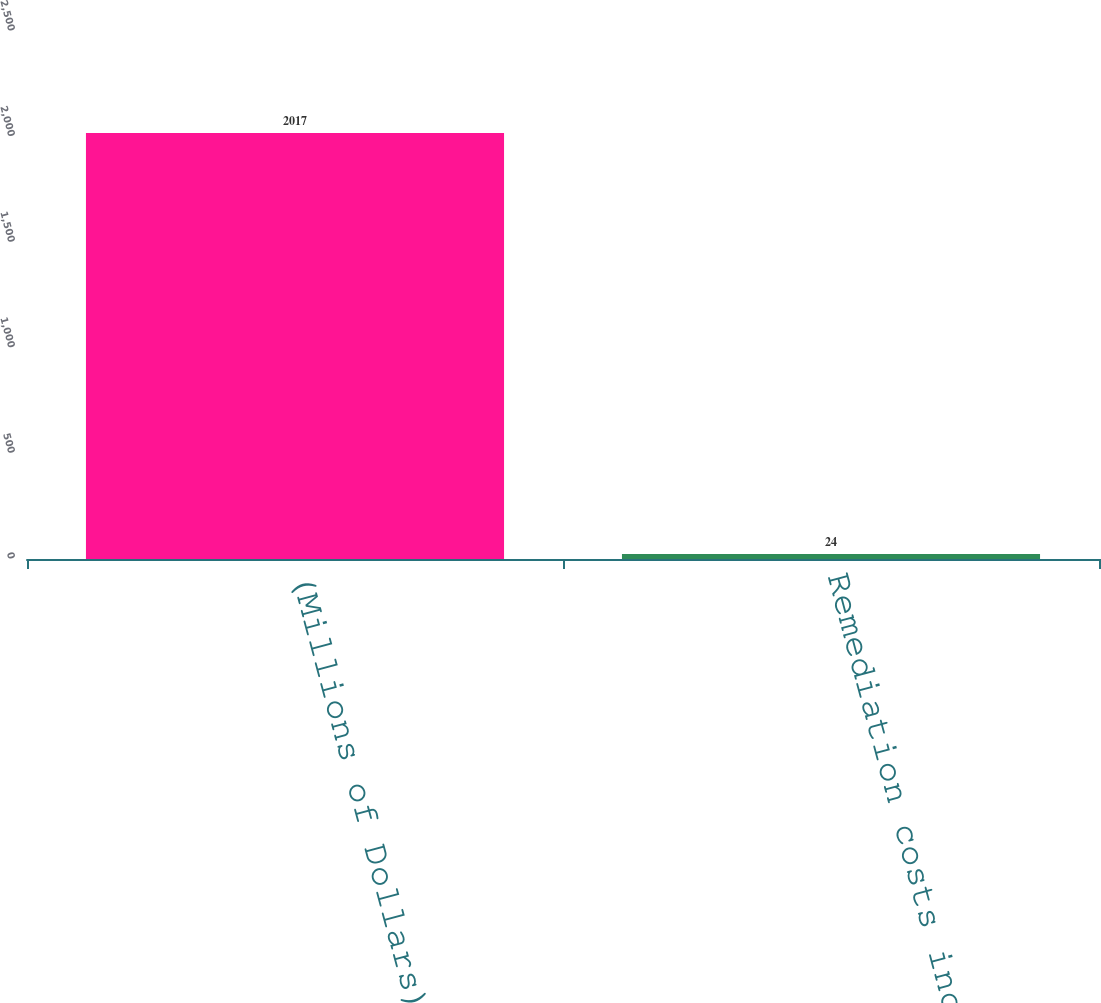Convert chart to OTSL. <chart><loc_0><loc_0><loc_500><loc_500><bar_chart><fcel>(Millions of Dollars)<fcel>Remediation costs incurred<nl><fcel>2017<fcel>24<nl></chart> 